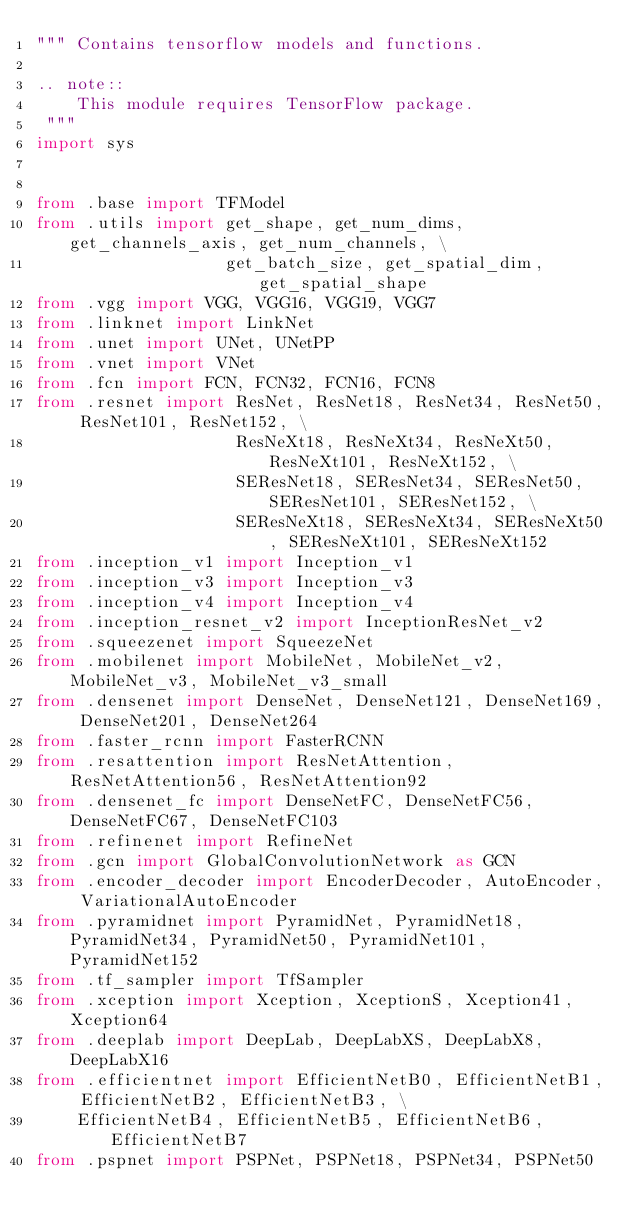<code> <loc_0><loc_0><loc_500><loc_500><_Python_>""" Contains tensorflow models and functions.

.. note::
    This module requires TensorFlow package.
 """
import sys


from .base import TFModel
from .utils import get_shape, get_num_dims, get_channels_axis, get_num_channels, \
                   get_batch_size, get_spatial_dim, get_spatial_shape
from .vgg import VGG, VGG16, VGG19, VGG7
from .linknet import LinkNet
from .unet import UNet, UNetPP
from .vnet import VNet
from .fcn import FCN, FCN32, FCN16, FCN8
from .resnet import ResNet, ResNet18, ResNet34, ResNet50, ResNet101, ResNet152, \
                    ResNeXt18, ResNeXt34, ResNeXt50, ResNeXt101, ResNeXt152, \
                    SEResNet18, SEResNet34, SEResNet50, SEResNet101, SEResNet152, \
                    SEResNeXt18, SEResNeXt34, SEResNeXt50, SEResNeXt101, SEResNeXt152
from .inception_v1 import Inception_v1
from .inception_v3 import Inception_v3
from .inception_v4 import Inception_v4
from .inception_resnet_v2 import InceptionResNet_v2
from .squeezenet import SqueezeNet
from .mobilenet import MobileNet, MobileNet_v2, MobileNet_v3, MobileNet_v3_small
from .densenet import DenseNet, DenseNet121, DenseNet169, DenseNet201, DenseNet264
from .faster_rcnn import FasterRCNN
from .resattention import ResNetAttention, ResNetAttention56, ResNetAttention92
from .densenet_fc import DenseNetFC, DenseNetFC56, DenseNetFC67, DenseNetFC103
from .refinenet import RefineNet
from .gcn import GlobalConvolutionNetwork as GCN
from .encoder_decoder import EncoderDecoder, AutoEncoder, VariationalAutoEncoder
from .pyramidnet import PyramidNet, PyramidNet18, PyramidNet34, PyramidNet50, PyramidNet101, PyramidNet152
from .tf_sampler import TfSampler
from .xception import Xception, XceptionS, Xception41, Xception64
from .deeplab import DeepLab, DeepLabXS, DeepLabX8, DeepLabX16
from .efficientnet import EfficientNetB0, EfficientNetB1, EfficientNetB2, EfficientNetB3, \
    EfficientNetB4, EfficientNetB5, EfficientNetB6, EfficientNetB7
from .pspnet import PSPNet, PSPNet18, PSPNet34, PSPNet50
</code> 